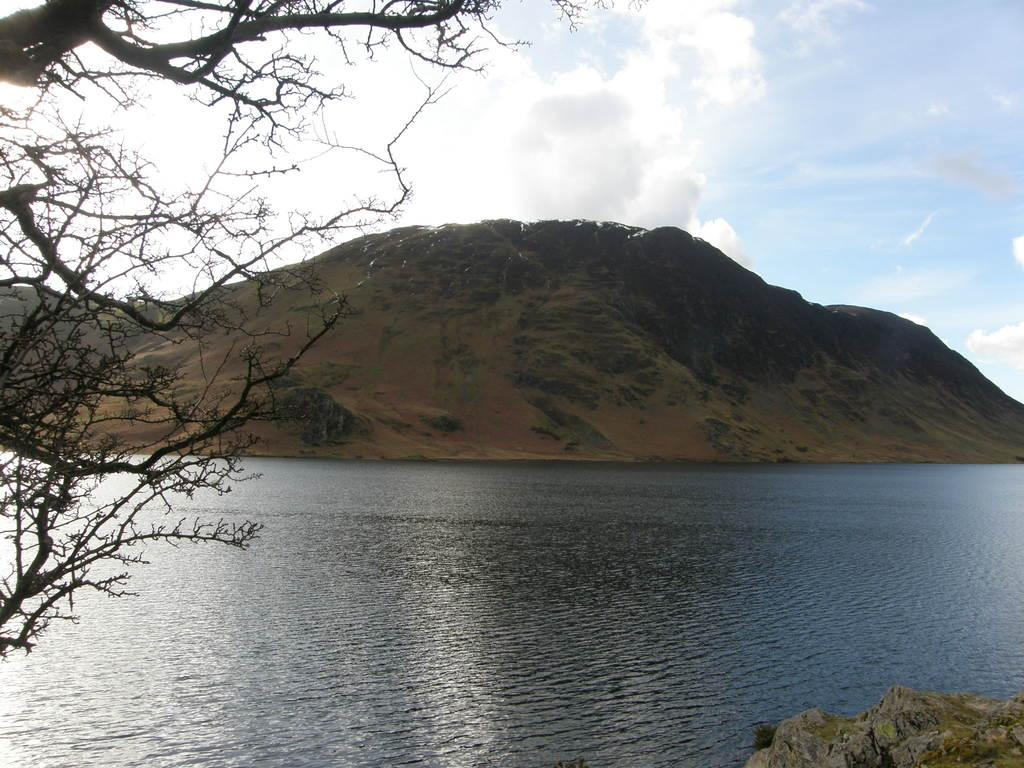What type of vegetation can be seen in the image? There are trees in the image. What natural element is visible in the image besides trees? There is water visible in the image. What type of landscape feature is present in the background of the image? There are mountains in the background of the image. How would you describe the sky in the image? The sky is cloudy in the background of the image. Where is the plantation located in the image? There is no plantation present in the image. How many birds can be seen flying in the image? There are no birds visible in the image. 